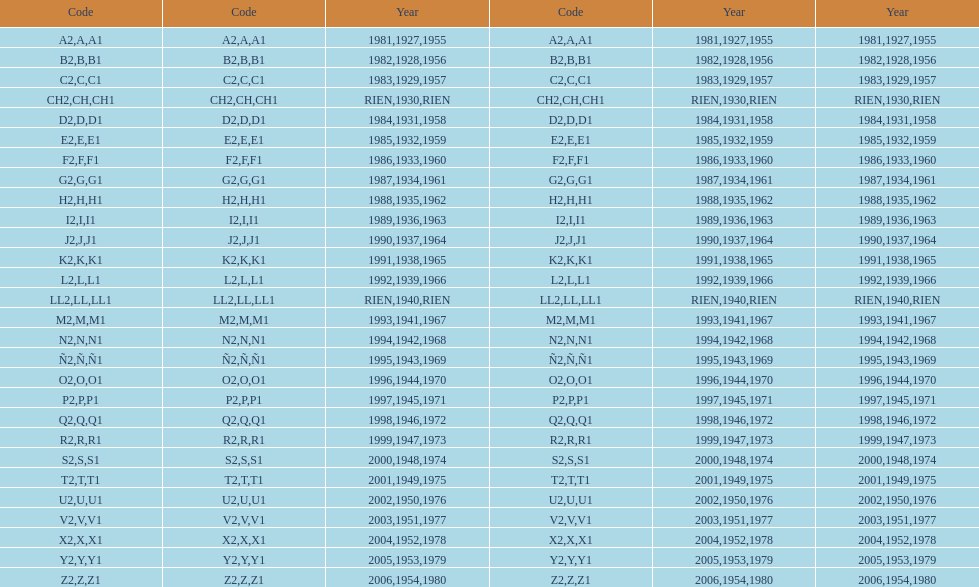What was the lowest year stamped? 1927. 